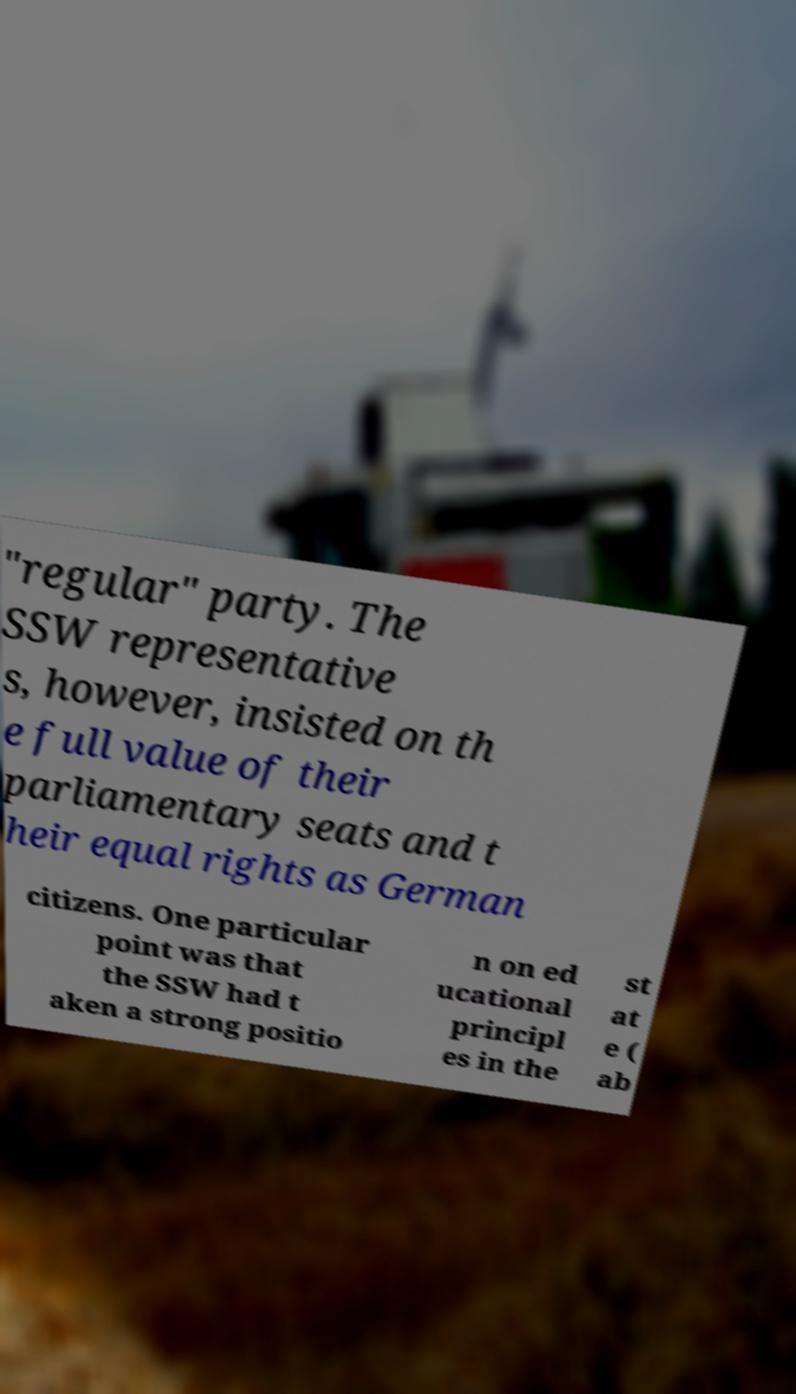There's text embedded in this image that I need extracted. Can you transcribe it verbatim? "regular" party. The SSW representative s, however, insisted on th e full value of their parliamentary seats and t heir equal rights as German citizens. One particular point was that the SSW had t aken a strong positio n on ed ucational principl es in the st at e ( ab 